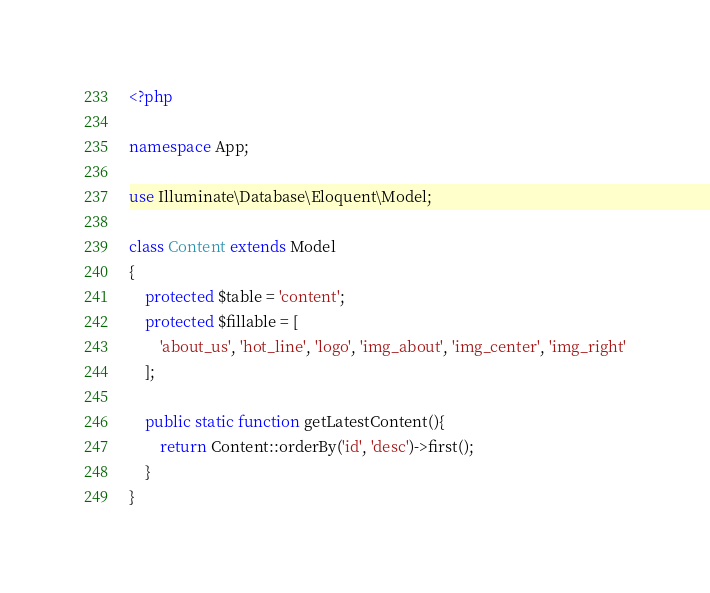<code> <loc_0><loc_0><loc_500><loc_500><_PHP_><?php

namespace App;

use Illuminate\Database\Eloquent\Model;

class Content extends Model
{
    protected $table = 'content';
    protected $fillable = [
        'about_us', 'hot_line', 'logo', 'img_about', 'img_center', 'img_right'
    ];

    public static function getLatestContent(){
        return Content::orderBy('id', 'desc')->first();
    }
}
</code> 